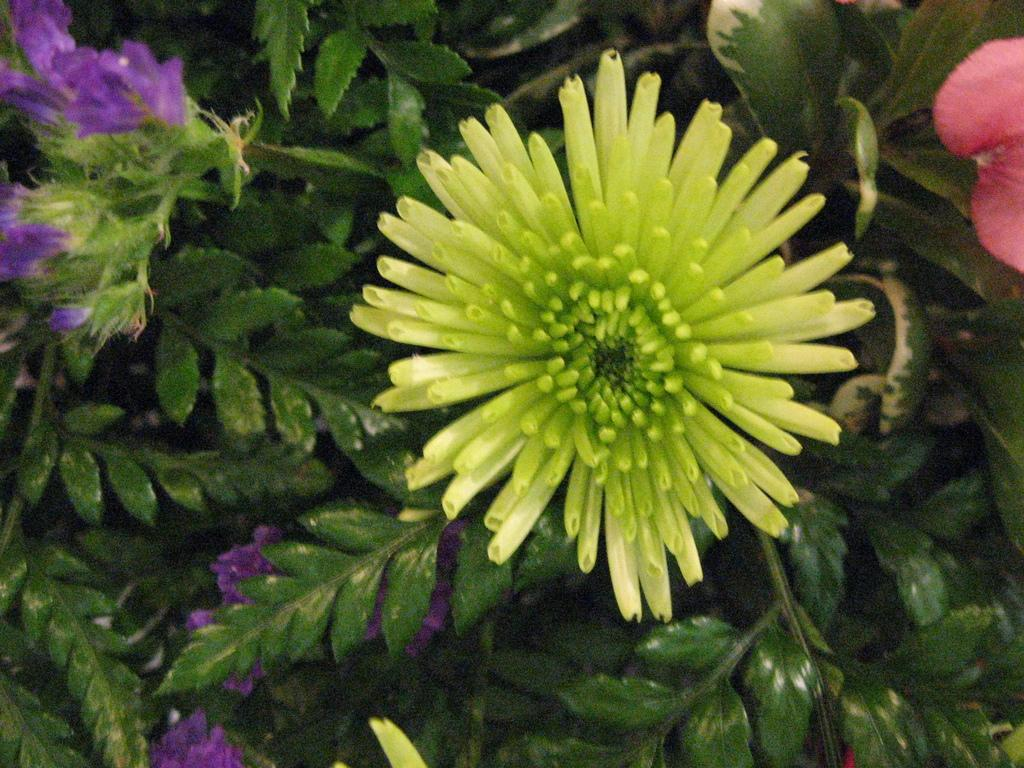What colors of flowers can be seen in the image? There are yellow, purple, and red flowers in the image. Can you describe the arrangement of the flowers in the image? The flowers are arranged in a way that allows leaves to be visible at the bottom of the image. How many scarecrows are present in the image? There are no scarecrows present in the image; it features flowers and leaves. 